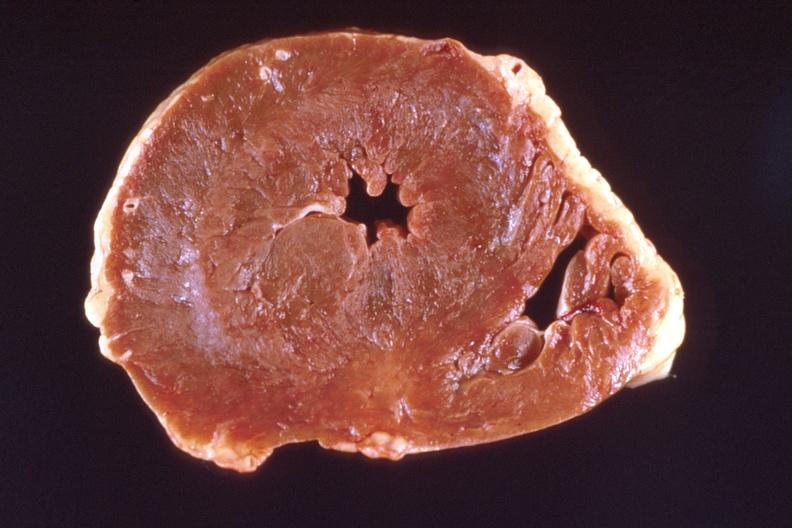what is marked left?
Answer the question using a single word or phrase. Ventricular hypertrophy 